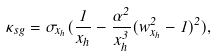<formula> <loc_0><loc_0><loc_500><loc_500>\kappa _ { s g } = \sigma _ { x _ { h } } ( \frac { 1 } { x _ { h } } - \frac { \alpha ^ { 2 } } { x _ { h } ^ { 3 } } ( w _ { x _ { h } } ^ { 2 } - 1 ) ^ { 2 } ) ,</formula> 